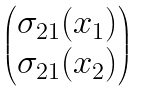<formula> <loc_0><loc_0><loc_500><loc_500>\begin{pmatrix} \sigma _ { 2 1 } ( x _ { 1 } ) \\ \sigma _ { 2 1 } ( x _ { 2 } ) \end{pmatrix}</formula> 